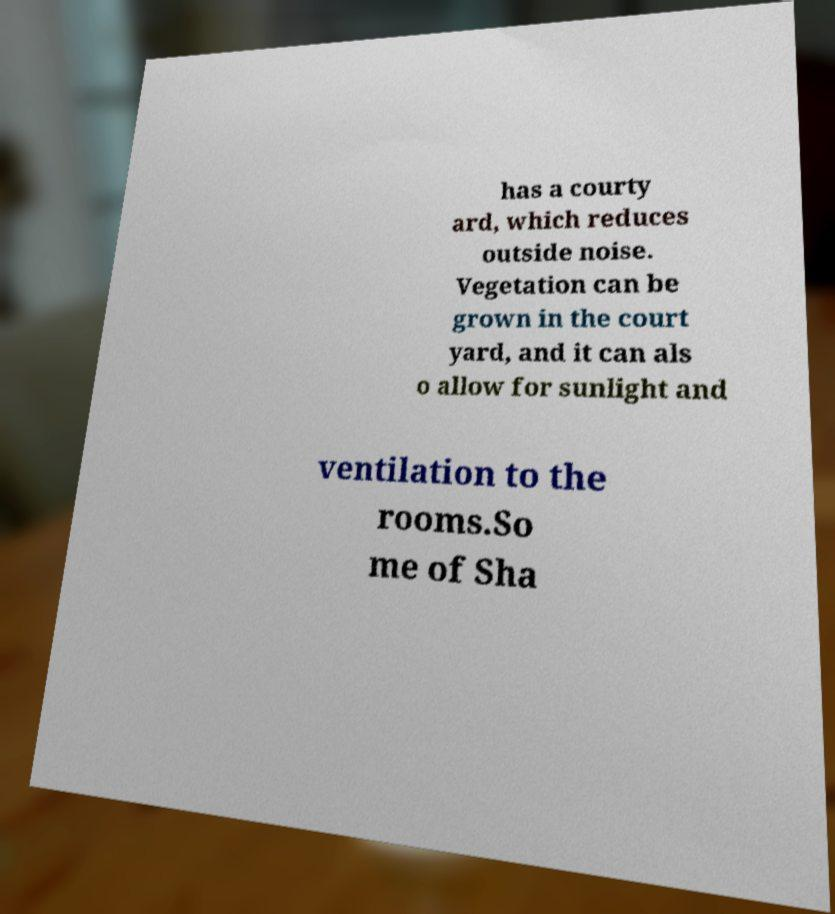Could you extract and type out the text from this image? has a courty ard, which reduces outside noise. Vegetation can be grown in the court yard, and it can als o allow for sunlight and ventilation to the rooms.So me of Sha 